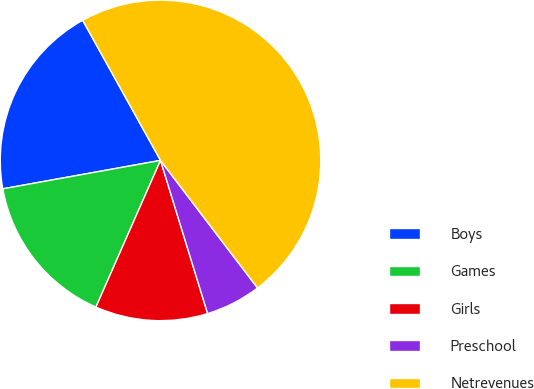Convert chart. <chart><loc_0><loc_0><loc_500><loc_500><pie_chart><fcel>Boys<fcel>Games<fcel>Girls<fcel>Preschool<fcel>Netrevenues<nl><fcel>19.77%<fcel>15.56%<fcel>11.35%<fcel>5.6%<fcel>47.72%<nl></chart> 